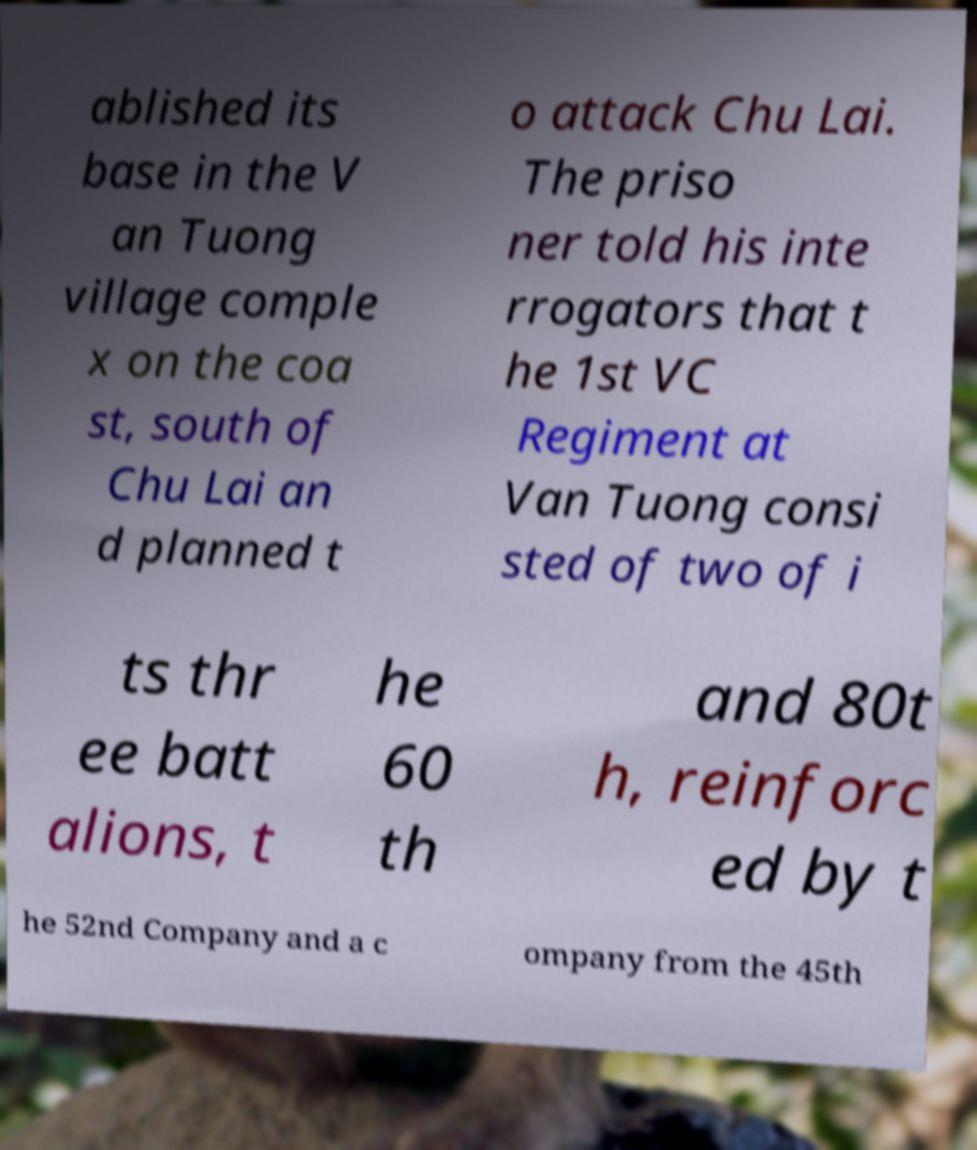I need the written content from this picture converted into text. Can you do that? ablished its base in the V an Tuong village comple x on the coa st, south of Chu Lai an d planned t o attack Chu Lai. The priso ner told his inte rrogators that t he 1st VC Regiment at Van Tuong consi sted of two of i ts thr ee batt alions, t he 60 th and 80t h, reinforc ed by t he 52nd Company and a c ompany from the 45th 